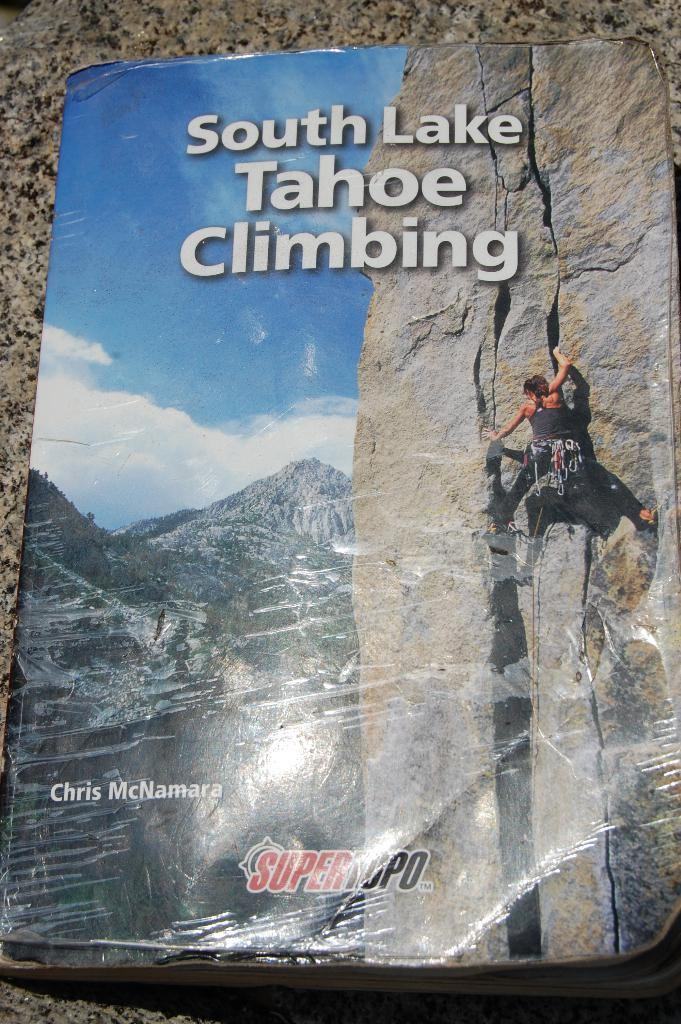What is featured on the poster in the image? There is a poster in the image that contains an image of hills. Can you describe the person on the poster? The person on the poster is wearing a black dress. What else can be seen in the background of the poster? The sky is visible on the poster, and there are clouds present. Is there any text on the poster? Yes, there is text written on the poster. Can you tell me how many times the calculator appears in the image? There is no calculator present in the image. What type of smile can be seen on the person's face in the image? There is no person visible in the image, only a poster with an image of a person wearing a black dress. 